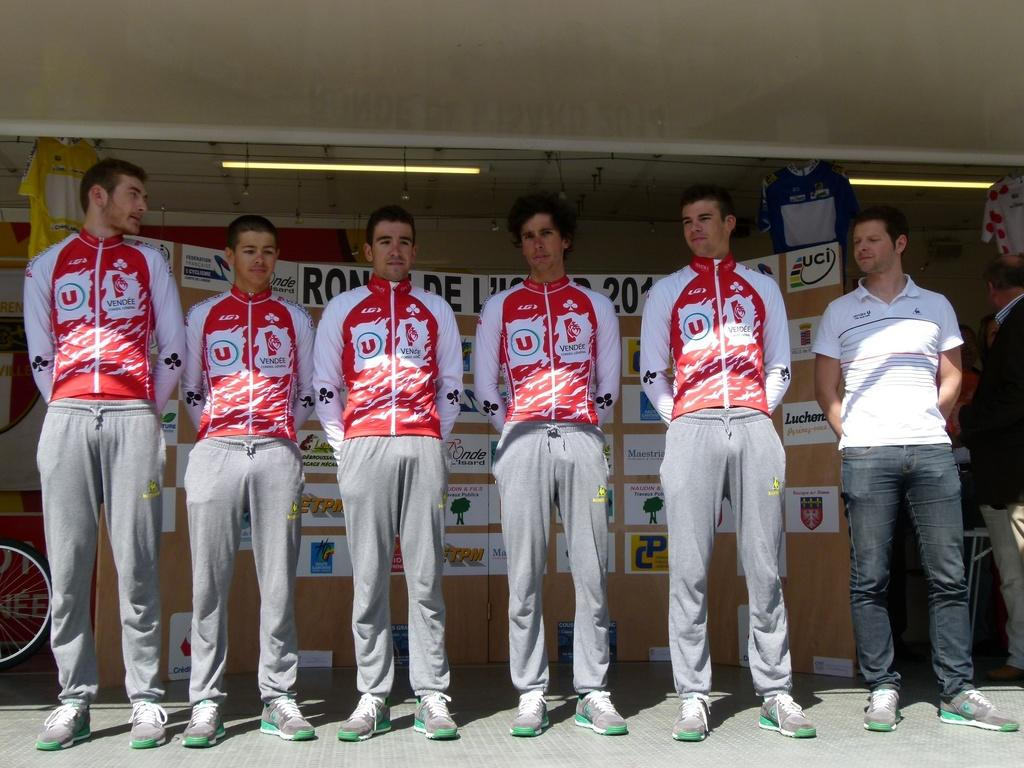<image>
Offer a succinct explanation of the picture presented. Men on a team stand in front of a billboard, the upper right of a billboard reads UCI. 